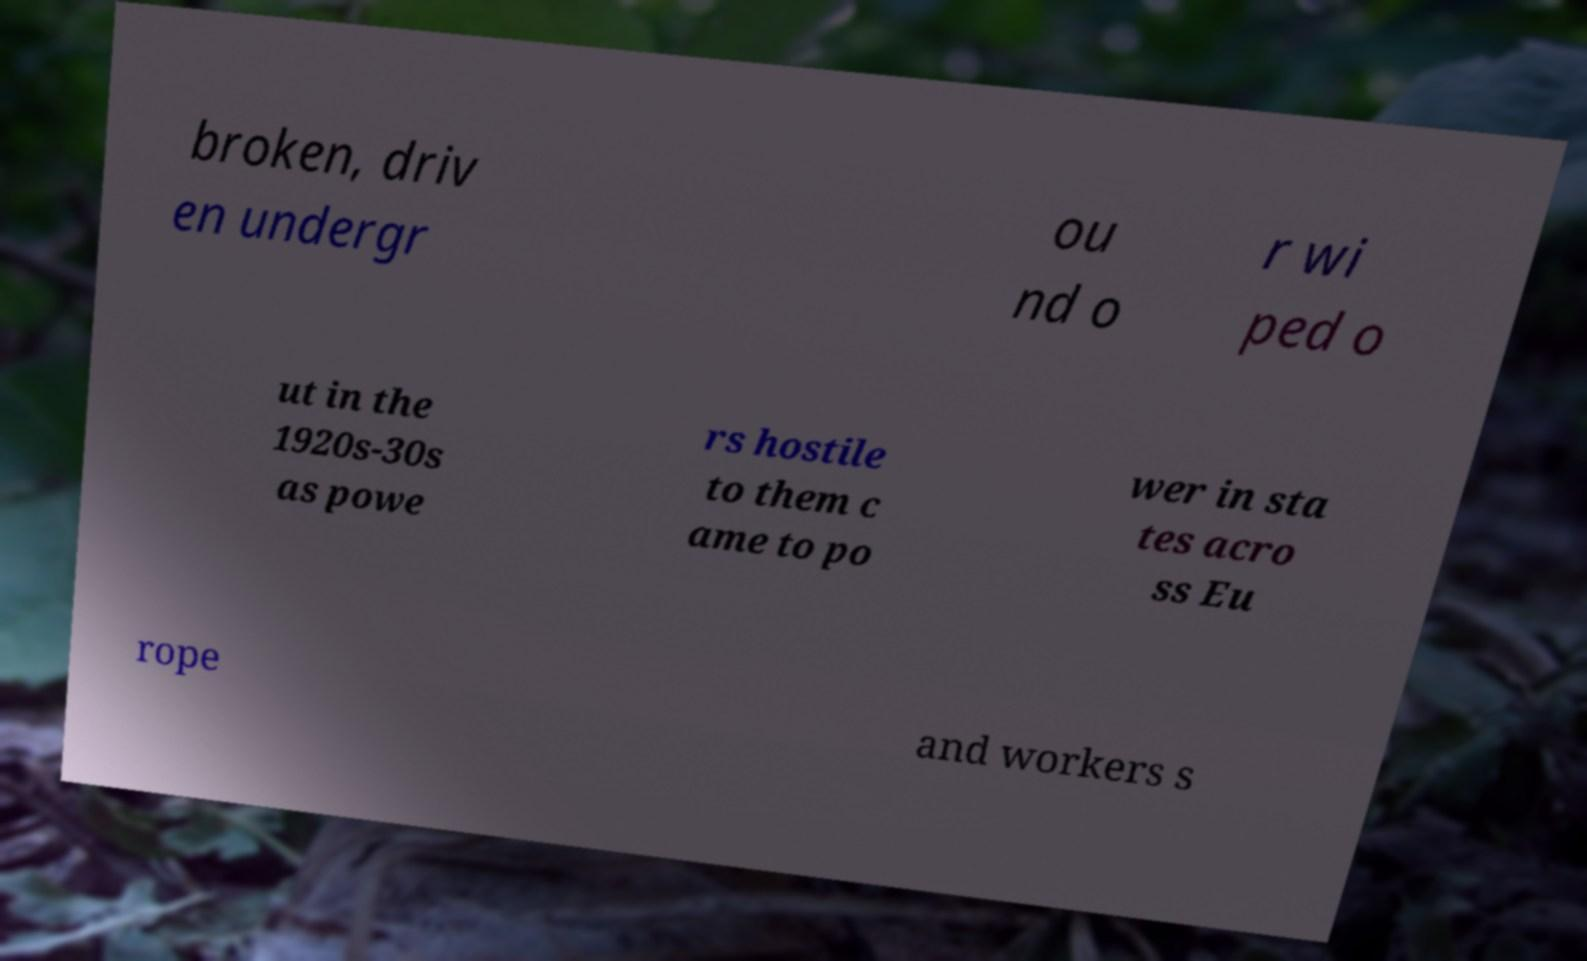Can you accurately transcribe the text from the provided image for me? broken, driv en undergr ou nd o r wi ped o ut in the 1920s-30s as powe rs hostile to them c ame to po wer in sta tes acro ss Eu rope and workers s 